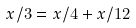<formula> <loc_0><loc_0><loc_500><loc_500>x / 3 = x / 4 + x / 1 2</formula> 